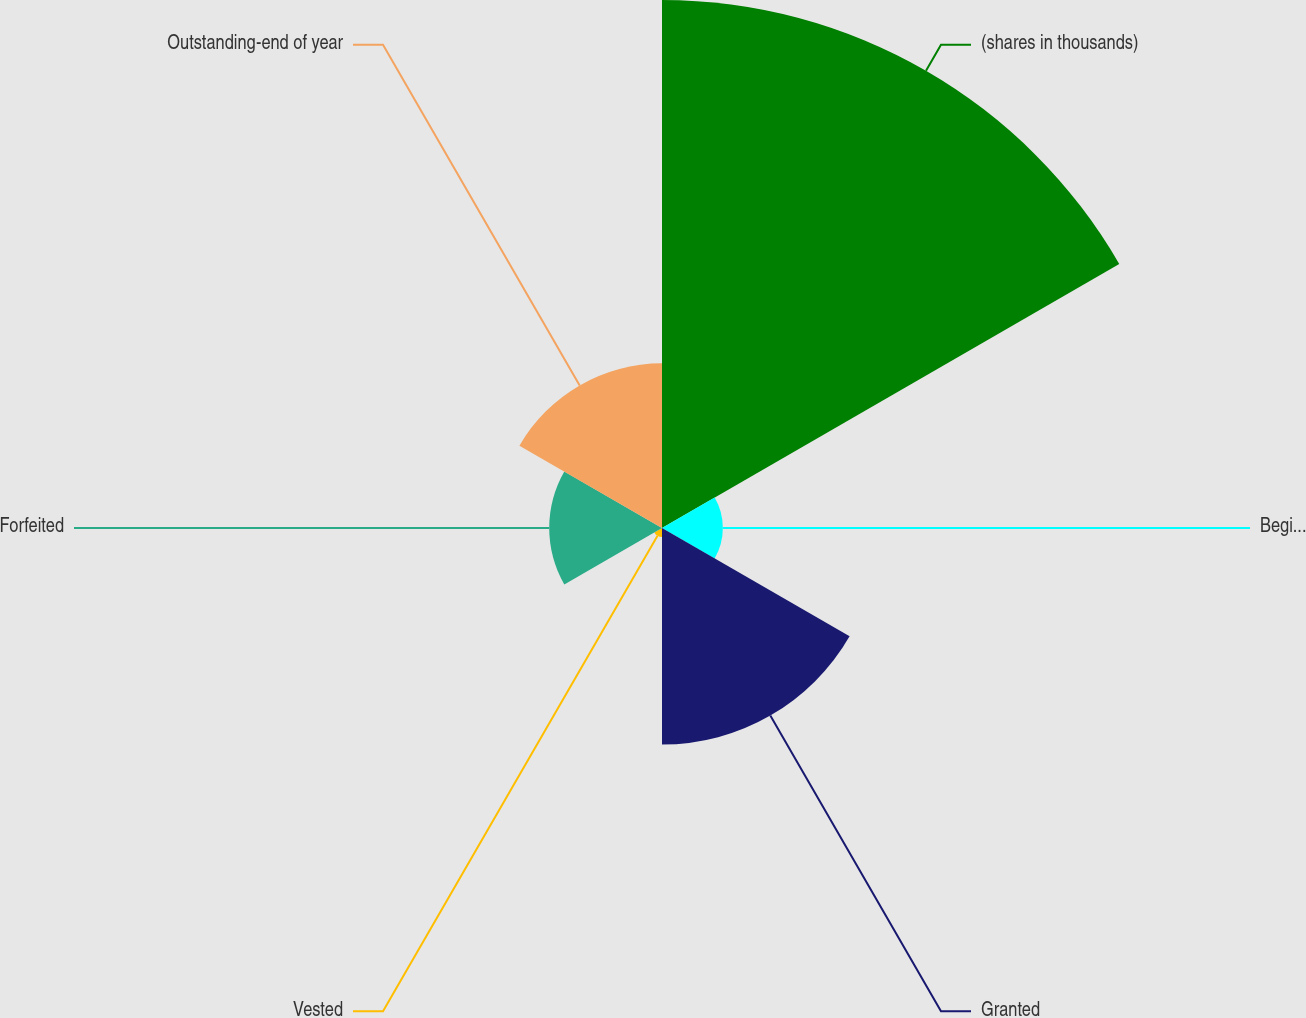Convert chart to OTSL. <chart><loc_0><loc_0><loc_500><loc_500><pie_chart><fcel>(shares in thousands)<fcel>Beginning of year<fcel>Granted<fcel>Vested<fcel>Forfeited<fcel>Outstanding-end of year<nl><fcel>48.36%<fcel>5.57%<fcel>19.84%<fcel>0.82%<fcel>10.33%<fcel>15.08%<nl></chart> 